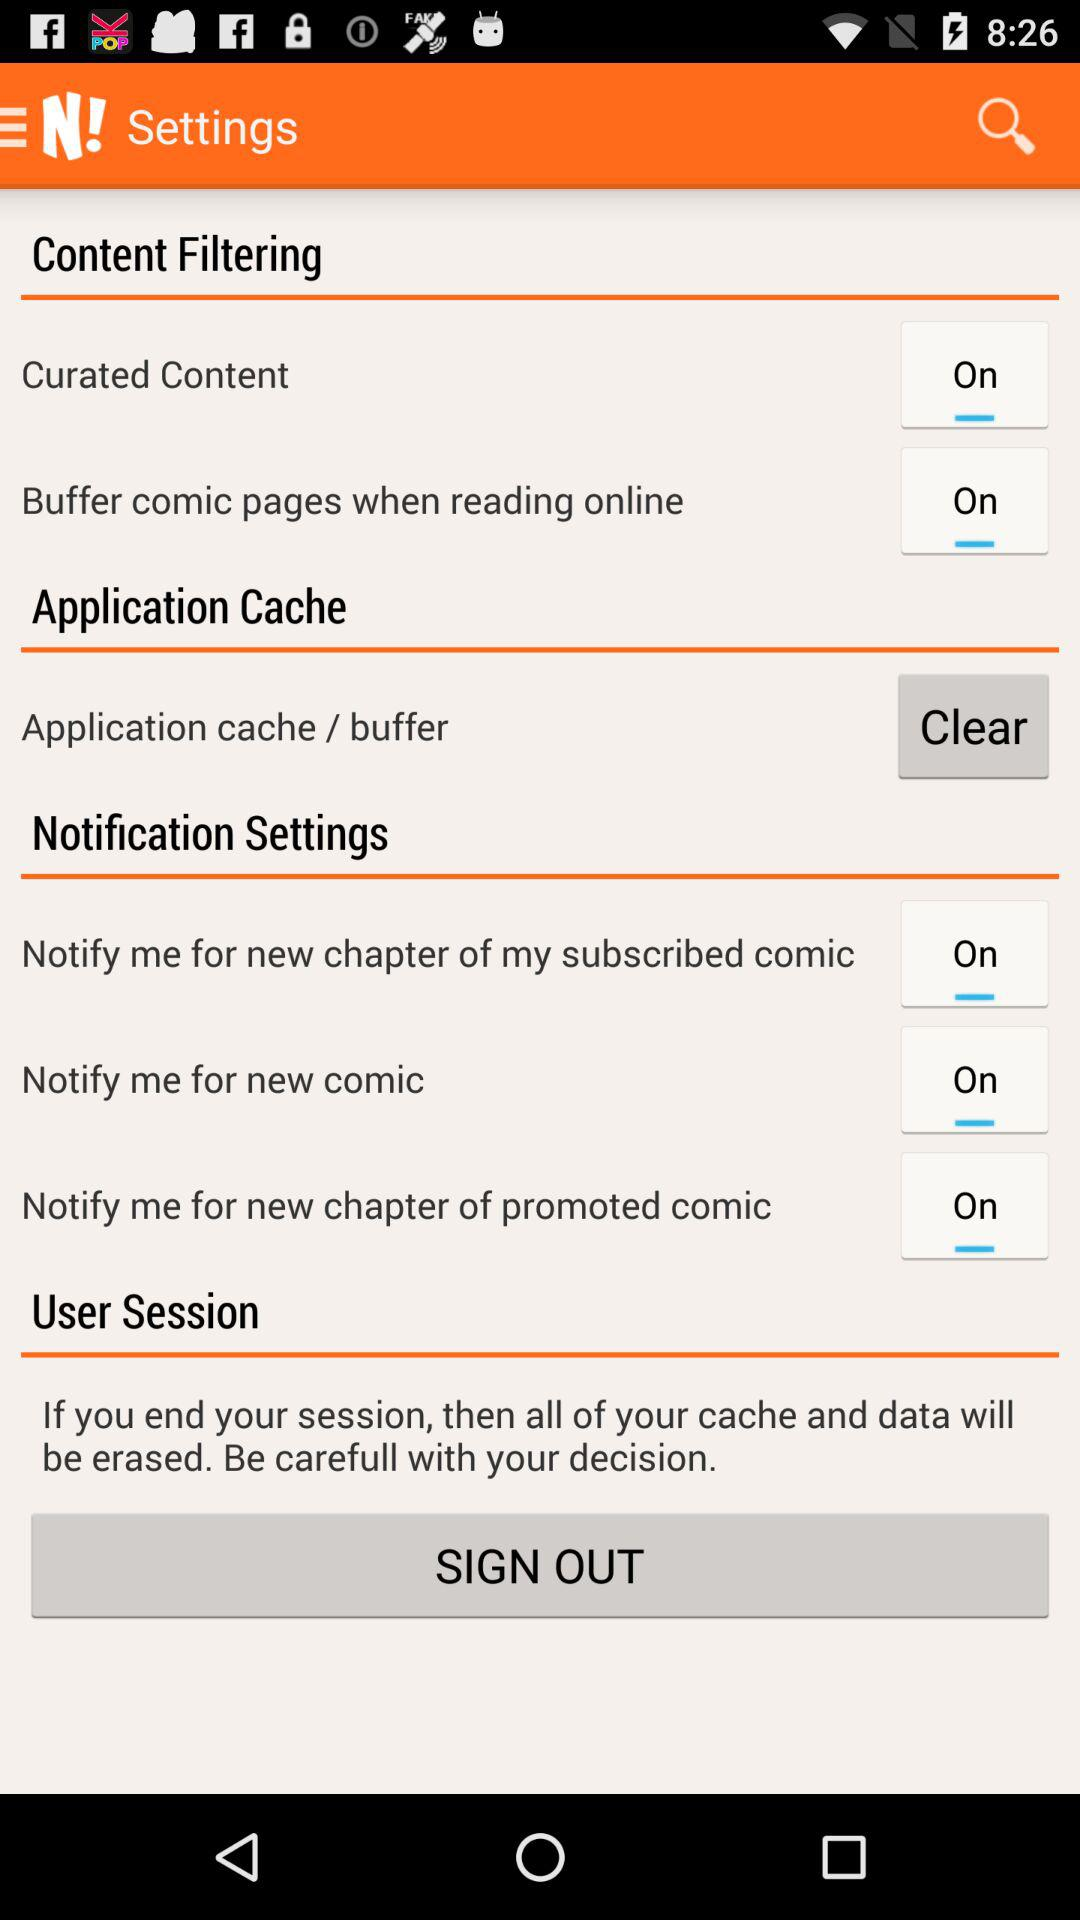Is "Curated Content" on or off? "Curated Content" is on. 